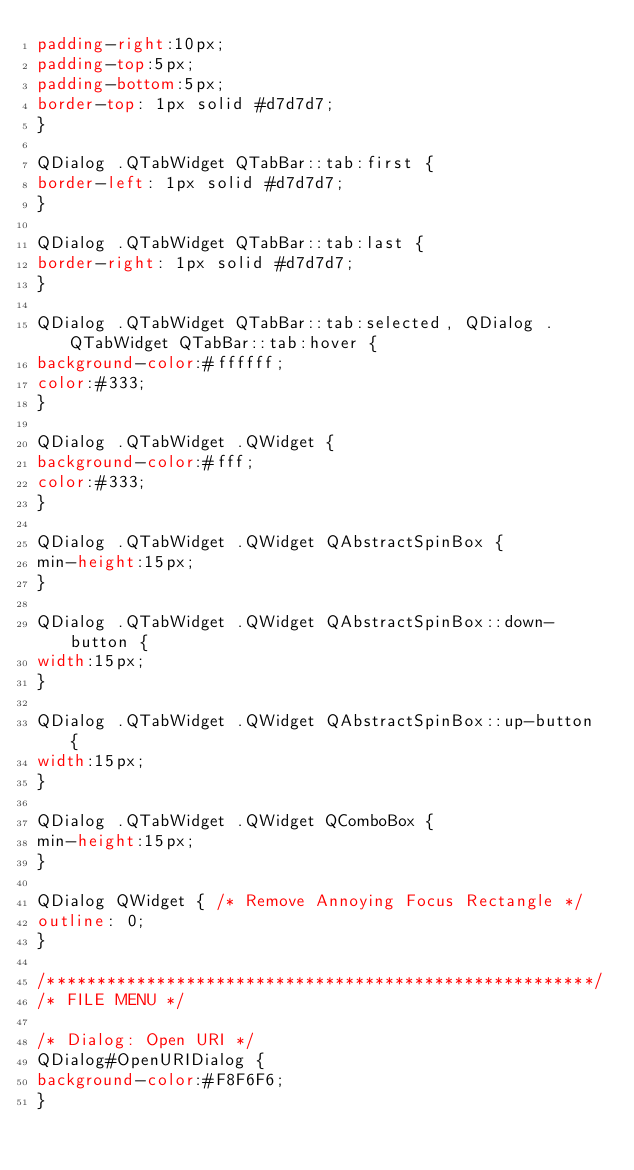<code> <loc_0><loc_0><loc_500><loc_500><_CSS_>padding-right:10px;
padding-top:5px;
padding-bottom:5px;
border-top: 1px solid #d7d7d7;
}

QDialog .QTabWidget QTabBar::tab:first {
border-left: 1px solid #d7d7d7;
}

QDialog .QTabWidget QTabBar::tab:last {
border-right: 1px solid #d7d7d7;
}

QDialog .QTabWidget QTabBar::tab:selected, QDialog .QTabWidget QTabBar::tab:hover {
background-color:#ffffff;
color:#333;
}

QDialog .QTabWidget .QWidget {
background-color:#fff;
color:#333;
}

QDialog .QTabWidget .QWidget QAbstractSpinBox {
min-height:15px;
}

QDialog .QTabWidget .QWidget QAbstractSpinBox::down-button {
width:15px;
}

QDialog .QTabWidget .QWidget QAbstractSpinBox::up-button {
width:15px;
}

QDialog .QTabWidget .QWidget QComboBox {
min-height:15px;
}

QDialog QWidget { /* Remove Annoying Focus Rectangle */
outline: 0;
}

/*******************************************************/
/* FILE MENU */

/* Dialog: Open URI */
QDialog#OpenURIDialog {
background-color:#F8F6F6;
}
</code> 